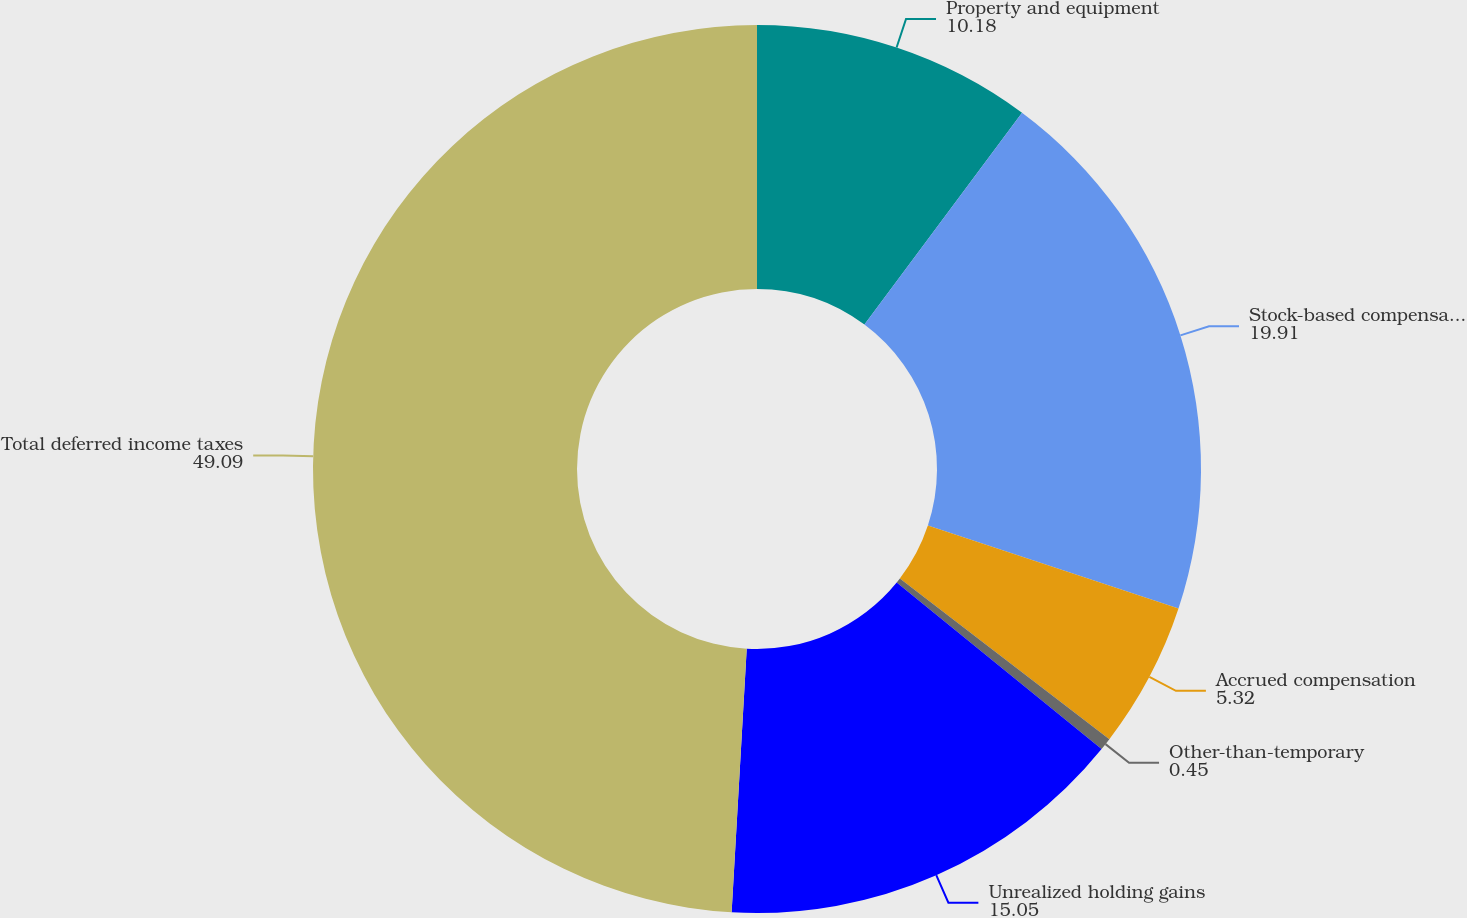<chart> <loc_0><loc_0><loc_500><loc_500><pie_chart><fcel>Property and equipment<fcel>Stock-based compensation<fcel>Accrued compensation<fcel>Other-than-temporary<fcel>Unrealized holding gains<fcel>Total deferred income taxes<nl><fcel>10.18%<fcel>19.91%<fcel>5.32%<fcel>0.45%<fcel>15.05%<fcel>49.09%<nl></chart> 